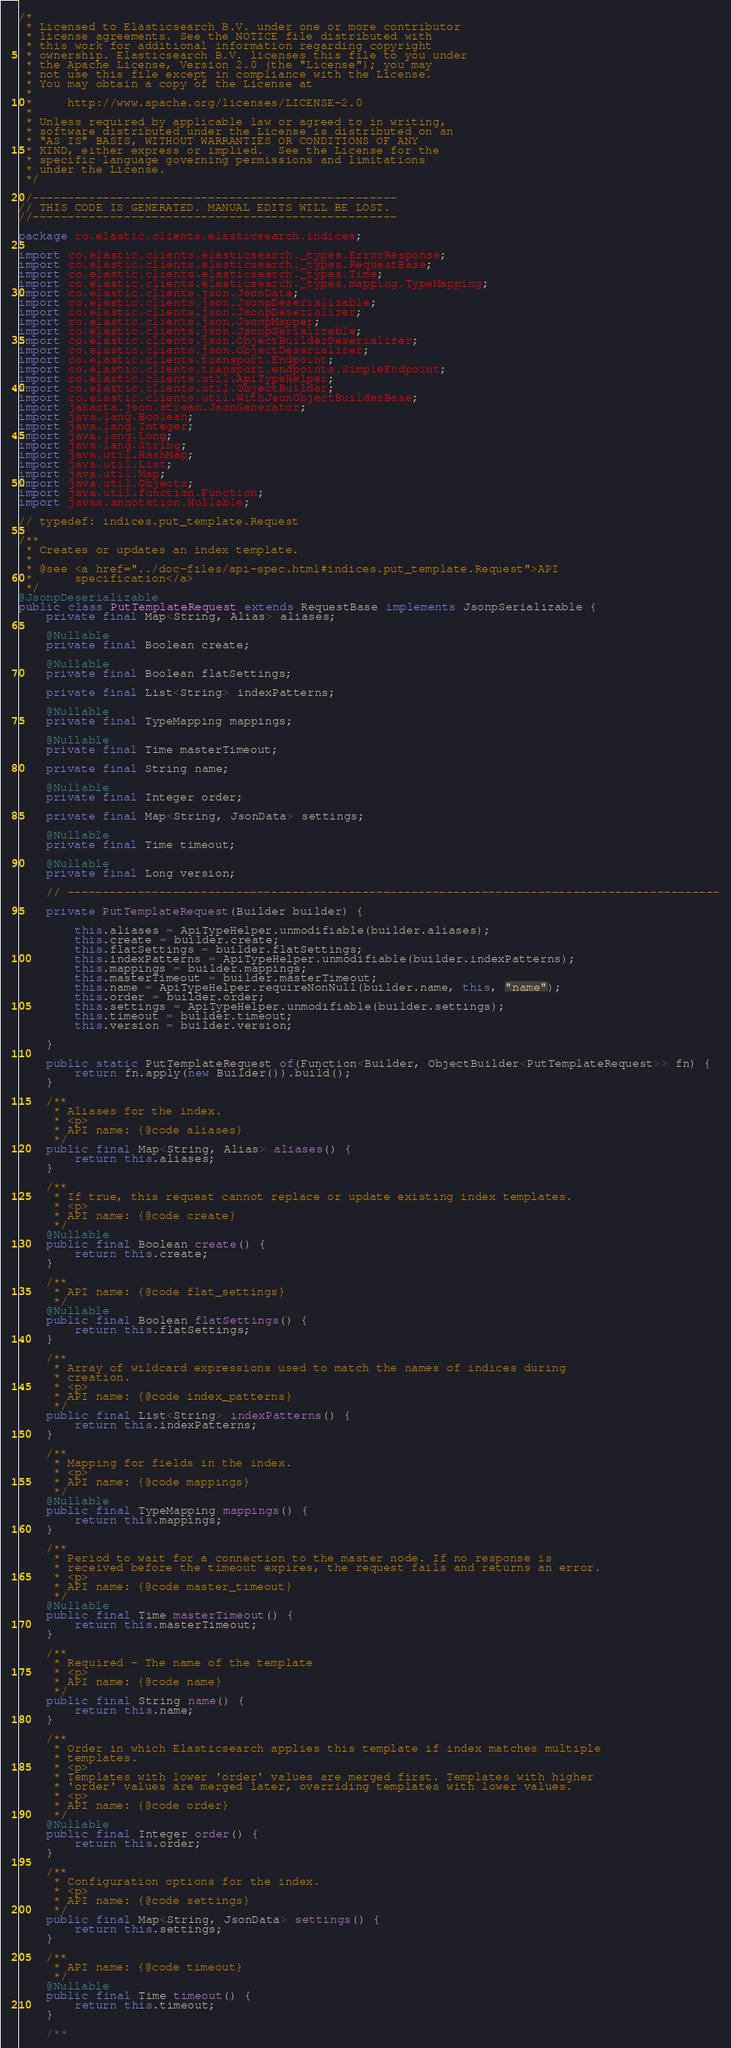<code> <loc_0><loc_0><loc_500><loc_500><_Java_>/*
 * Licensed to Elasticsearch B.V. under one or more contributor
 * license agreements. See the NOTICE file distributed with
 * this work for additional information regarding copyright
 * ownership. Elasticsearch B.V. licenses this file to you under
 * the Apache License, Version 2.0 (the "License"); you may
 * not use this file except in compliance with the License.
 * You may obtain a copy of the License at
 *
 *     http://www.apache.org/licenses/LICENSE-2.0
 *
 * Unless required by applicable law or agreed to in writing,
 * software distributed under the License is distributed on an
 * "AS IS" BASIS, WITHOUT WARRANTIES OR CONDITIONS OF ANY
 * KIND, either express or implied.  See the License for the
 * specific language governing permissions and limitations
 * under the License.
 */

//----------------------------------------------------
// THIS CODE IS GENERATED. MANUAL EDITS WILL BE LOST.
//----------------------------------------------------

package co.elastic.clients.elasticsearch.indices;

import co.elastic.clients.elasticsearch._types.ErrorResponse;
import co.elastic.clients.elasticsearch._types.RequestBase;
import co.elastic.clients.elasticsearch._types.Time;
import co.elastic.clients.elasticsearch._types.mapping.TypeMapping;
import co.elastic.clients.json.JsonData;
import co.elastic.clients.json.JsonpDeserializable;
import co.elastic.clients.json.JsonpDeserializer;
import co.elastic.clients.json.JsonpMapper;
import co.elastic.clients.json.JsonpSerializable;
import co.elastic.clients.json.ObjectBuilderDeserializer;
import co.elastic.clients.json.ObjectDeserializer;
import co.elastic.clients.transport.Endpoint;
import co.elastic.clients.transport.endpoints.SimpleEndpoint;
import co.elastic.clients.util.ApiTypeHelper;
import co.elastic.clients.util.ObjectBuilder;
import co.elastic.clients.util.WithJsonObjectBuilderBase;
import jakarta.json.stream.JsonGenerator;
import java.lang.Boolean;
import java.lang.Integer;
import java.lang.Long;
import java.lang.String;
import java.util.HashMap;
import java.util.List;
import java.util.Map;
import java.util.Objects;
import java.util.function.Function;
import javax.annotation.Nullable;

// typedef: indices.put_template.Request

/**
 * Creates or updates an index template.
 * 
 * @see <a href="../doc-files/api-spec.html#indices.put_template.Request">API
 *      specification</a>
 */
@JsonpDeserializable
public class PutTemplateRequest extends RequestBase implements JsonpSerializable {
	private final Map<String, Alias> aliases;

	@Nullable
	private final Boolean create;

	@Nullable
	private final Boolean flatSettings;

	private final List<String> indexPatterns;

	@Nullable
	private final TypeMapping mappings;

	@Nullable
	private final Time masterTimeout;

	private final String name;

	@Nullable
	private final Integer order;

	private final Map<String, JsonData> settings;

	@Nullable
	private final Time timeout;

	@Nullable
	private final Long version;

	// ---------------------------------------------------------------------------------------------

	private PutTemplateRequest(Builder builder) {

		this.aliases = ApiTypeHelper.unmodifiable(builder.aliases);
		this.create = builder.create;
		this.flatSettings = builder.flatSettings;
		this.indexPatterns = ApiTypeHelper.unmodifiable(builder.indexPatterns);
		this.mappings = builder.mappings;
		this.masterTimeout = builder.masterTimeout;
		this.name = ApiTypeHelper.requireNonNull(builder.name, this, "name");
		this.order = builder.order;
		this.settings = ApiTypeHelper.unmodifiable(builder.settings);
		this.timeout = builder.timeout;
		this.version = builder.version;

	}

	public static PutTemplateRequest of(Function<Builder, ObjectBuilder<PutTemplateRequest>> fn) {
		return fn.apply(new Builder()).build();
	}

	/**
	 * Aliases for the index.
	 * <p>
	 * API name: {@code aliases}
	 */
	public final Map<String, Alias> aliases() {
		return this.aliases;
	}

	/**
	 * If true, this request cannot replace or update existing index templates.
	 * <p>
	 * API name: {@code create}
	 */
	@Nullable
	public final Boolean create() {
		return this.create;
	}

	/**
	 * API name: {@code flat_settings}
	 */
	@Nullable
	public final Boolean flatSettings() {
		return this.flatSettings;
	}

	/**
	 * Array of wildcard expressions used to match the names of indices during
	 * creation.
	 * <p>
	 * API name: {@code index_patterns}
	 */
	public final List<String> indexPatterns() {
		return this.indexPatterns;
	}

	/**
	 * Mapping for fields in the index.
	 * <p>
	 * API name: {@code mappings}
	 */
	@Nullable
	public final TypeMapping mappings() {
		return this.mappings;
	}

	/**
	 * Period to wait for a connection to the master node. If no response is
	 * received before the timeout expires, the request fails and returns an error.
	 * <p>
	 * API name: {@code master_timeout}
	 */
	@Nullable
	public final Time masterTimeout() {
		return this.masterTimeout;
	}

	/**
	 * Required - The name of the template
	 * <p>
	 * API name: {@code name}
	 */
	public final String name() {
		return this.name;
	}

	/**
	 * Order in which Elasticsearch applies this template if index matches multiple
	 * templates.
	 * <p>
	 * Templates with lower 'order' values are merged first. Templates with higher
	 * 'order' values are merged later, overriding templates with lower values.
	 * <p>
	 * API name: {@code order}
	 */
	@Nullable
	public final Integer order() {
		return this.order;
	}

	/**
	 * Configuration options for the index.
	 * <p>
	 * API name: {@code settings}
	 */
	public final Map<String, JsonData> settings() {
		return this.settings;
	}

	/**
	 * API name: {@code timeout}
	 */
	@Nullable
	public final Time timeout() {
		return this.timeout;
	}

	/**</code> 